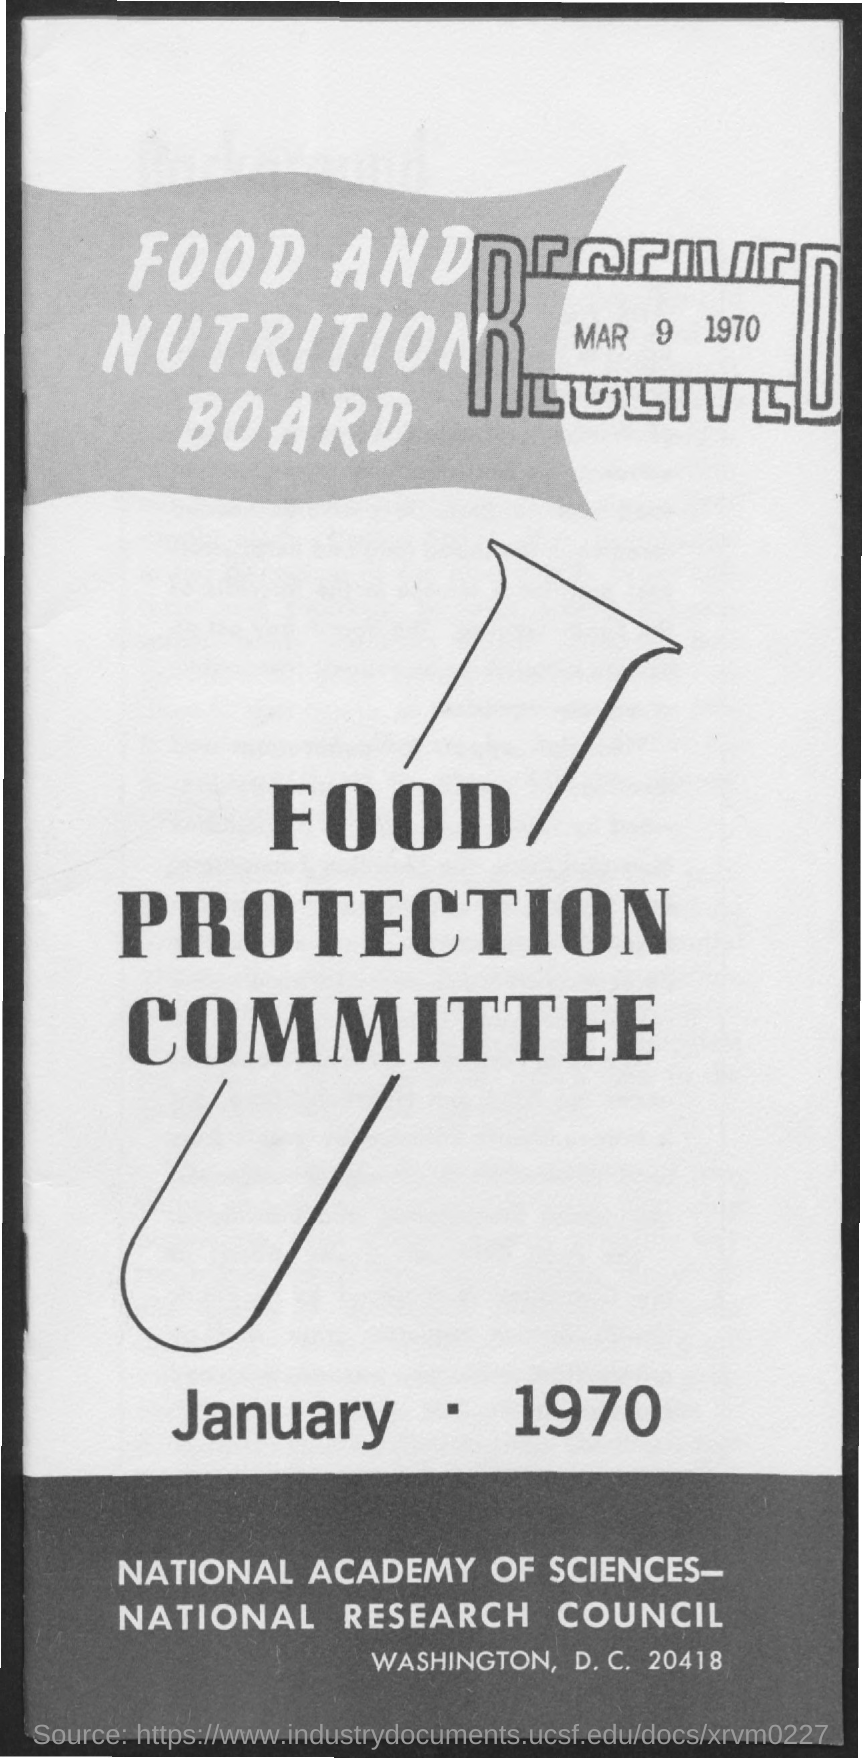Find the received date?
Offer a very short reply. Mar 9, 1970. 